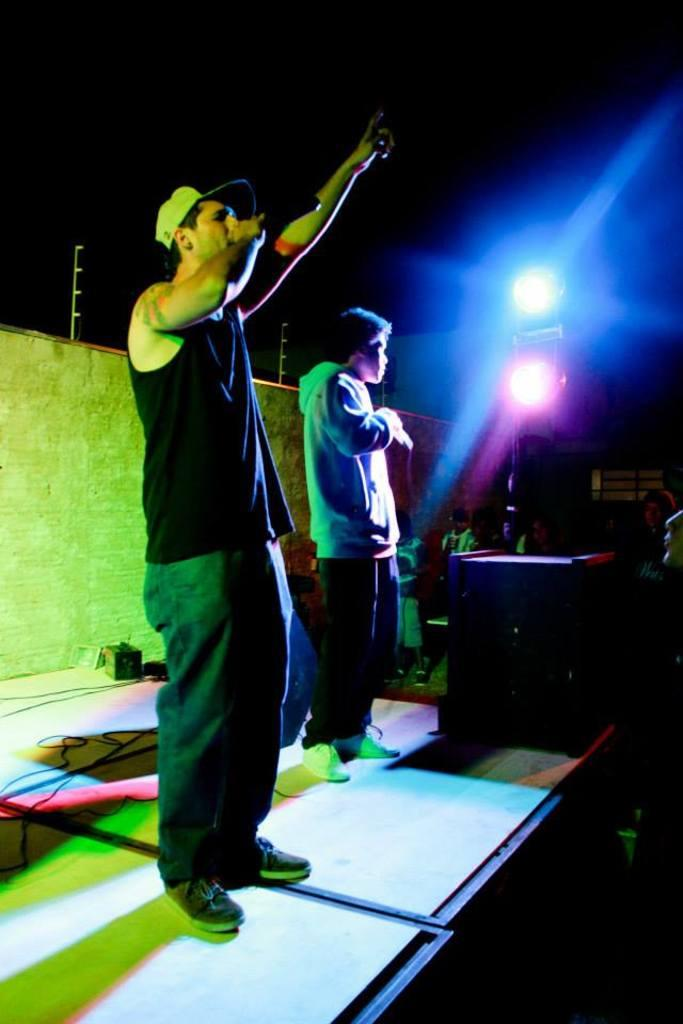Who or what can be seen in the image? There are people in the image. What is located on the right side of the image? There are lights on the right side of the image. What is at the bottom of the image? There is a dais at the bottom of the image. What is on the dais? A speaker is present on the dais. What can be seen in the background of the image? There is a wall in the background of the image, and wires are visible in the background. What type of chair is visible in the image? There is no chair present in the image. What is the size of the speaker on the dais? The size of the speaker cannot be determined from the image alone. 